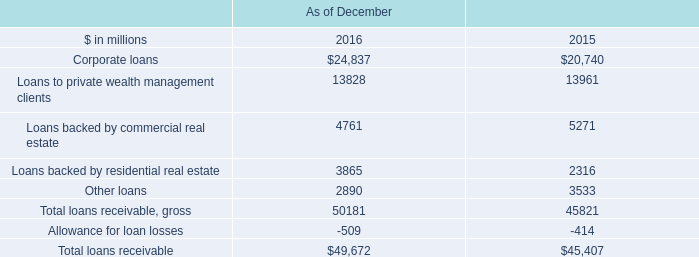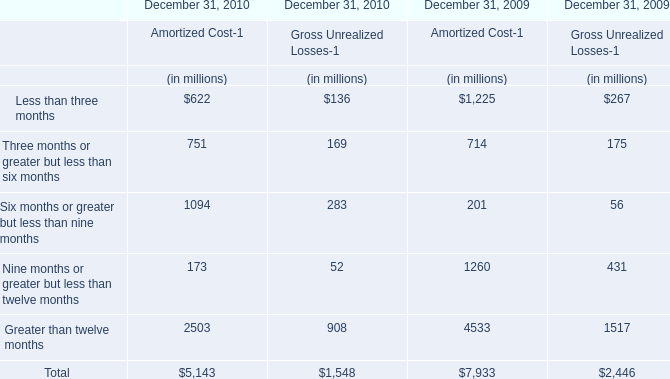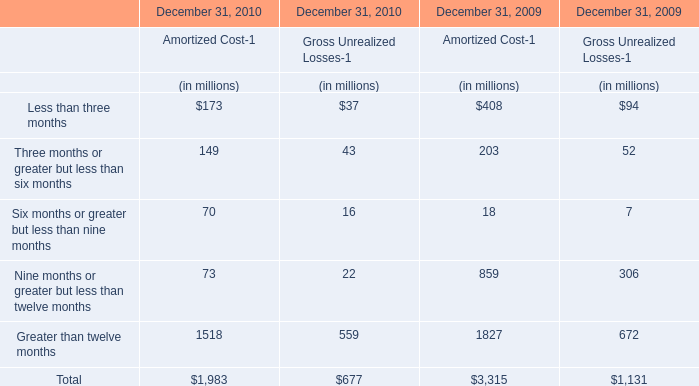At December 31, 2010,what is the ratio of the Gross Unrealized Losses for Six months or greater but less than nine months to the Gross Unrealized Losses for Total ? 
Computations: (283 / 1548)
Answer: 0.18282. 